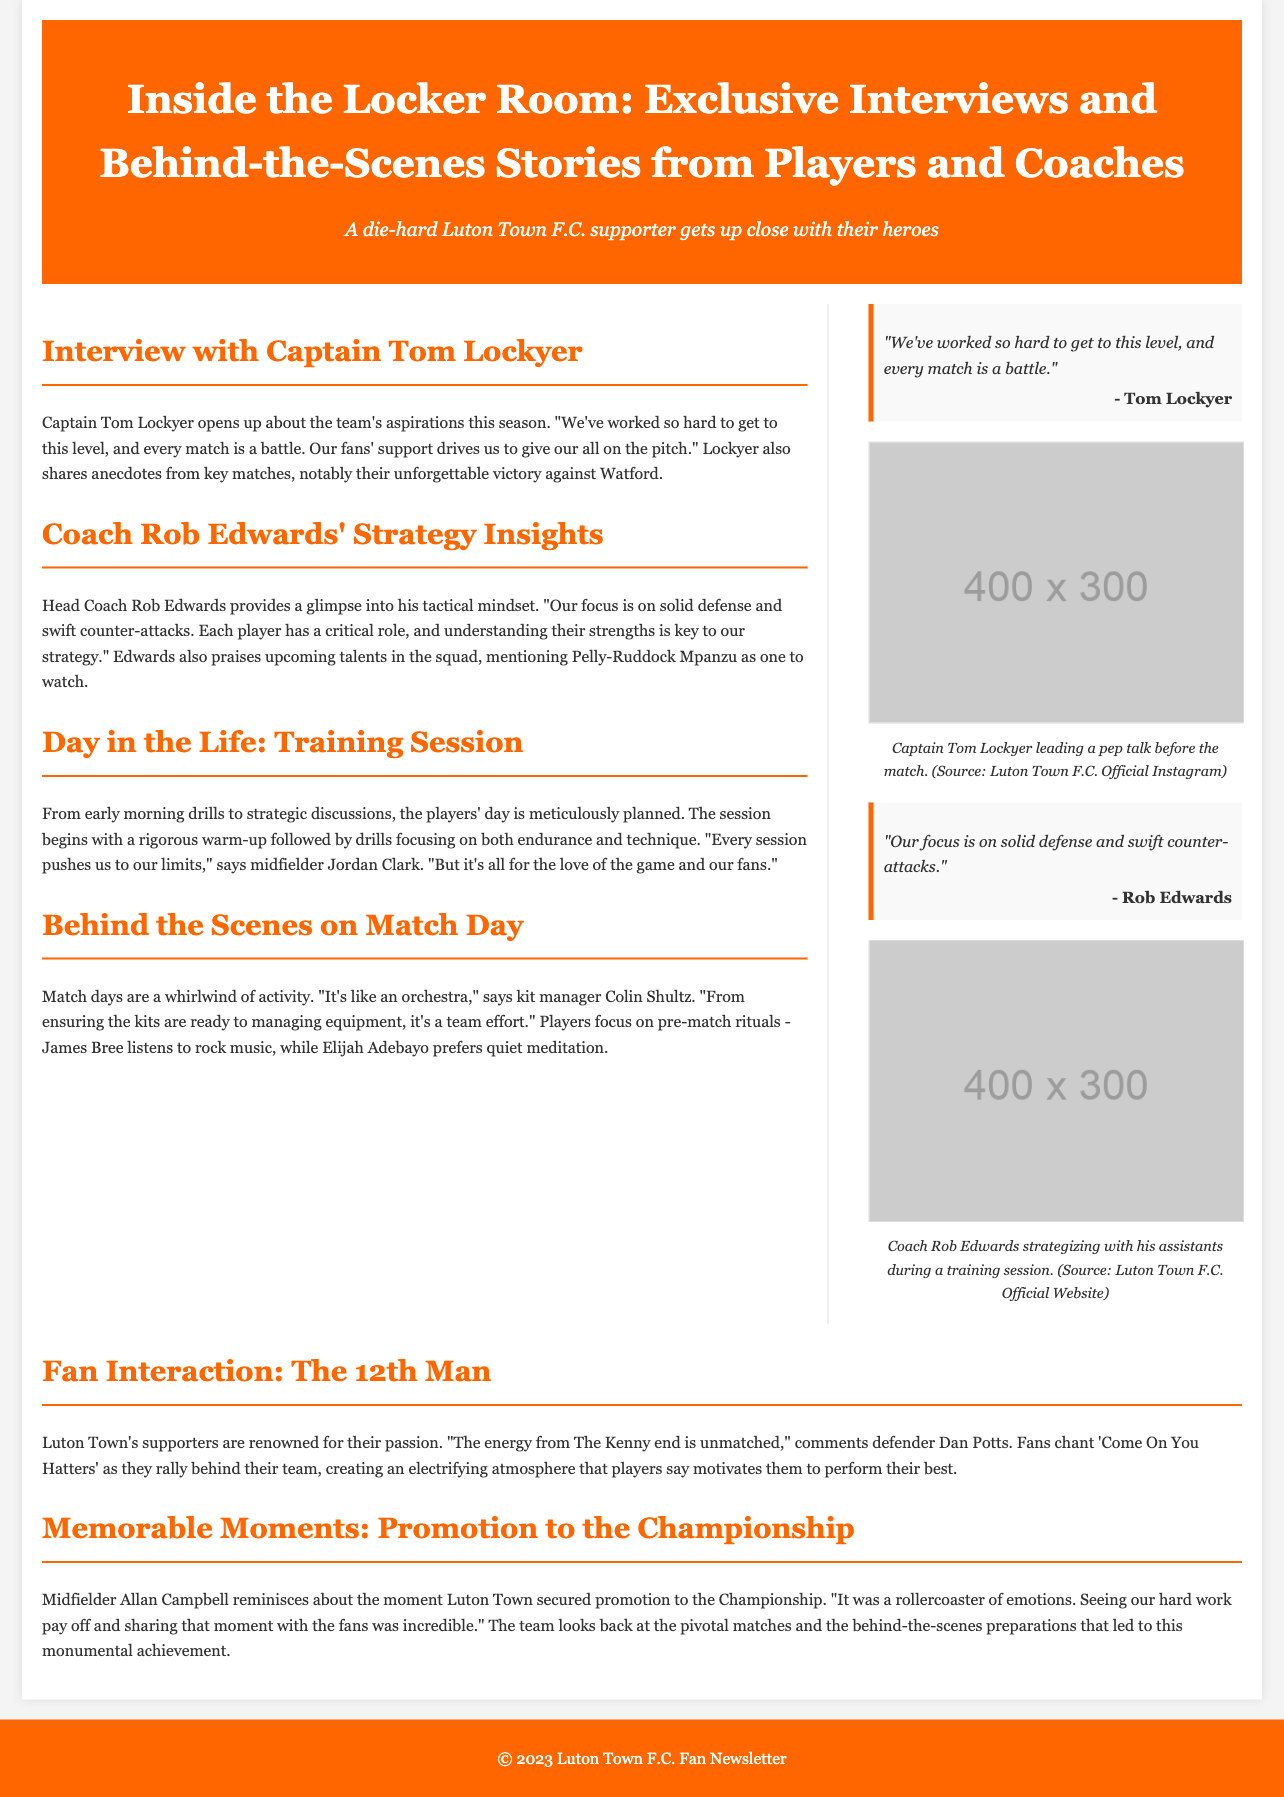what is the title of the document? The title of the document is prominently displayed at the top, introducing the theme of exclusive player and coach insights.
Answer: Inside the Locker Room: Exclusive Interviews and Behind-the-Scenes Stories from Players and Coaches who is the captain of Luton Town F.C.? The document mentions the captain in the interview section with his name.
Answer: Tom Lockyer what tactical focus does Coach Rob Edwards emphasize? The document provides insights from the coach regarding the team's strategy, particularly highlighting key tactical aspects.
Answer: Solid defense and swift counter-attacks who shared memorable moments about promotion to the Championship? The document identifies the player reminiscing about the promotion achievement.
Answer: Allan Campbell what chant do Luton Town fans use to rally behind their team? The document includes a quote emphasizing the fans' rallying cry during matches.
Answer: Come On You Hatters how does kit manager Colin Shultz describe match days? Colin Shultz provides a metaphor to describe the organized chaos of match days in the document.
Answer: An orchestra who is highlighted as a player to watch in the squad? Coach Rob Edwards mentions a specific player as promising in a tactical discussion.
Answer: Pelly-Ruddock Mpanzu what emotional experience does Allan Campbell describe? The document recounts the emotions connected to a significant achievement for the team.
Answer: Rollercoaster of emotions 